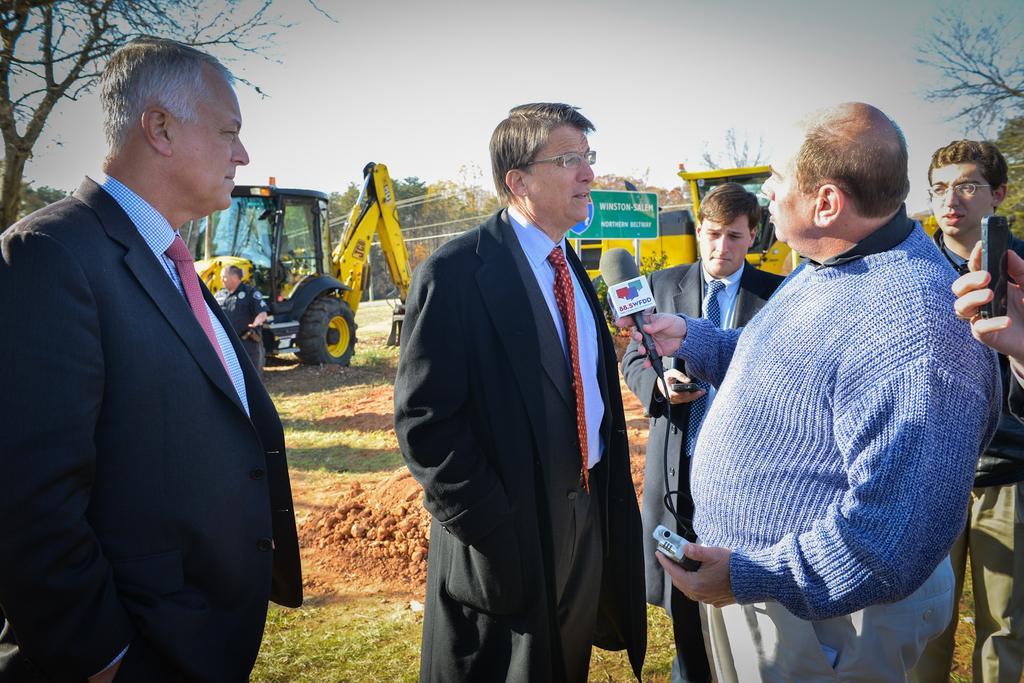In one or two sentences, can you explain what this image depicts? In this image I can see there are four persons wearing a black color jacket and I can see a person standing in front of them holding a mike and on the right side I can see a person hand which is holding a mobile and at the top I can see the sky and in the middle I can see yellow color tracks and on the left side I can see a tree. 